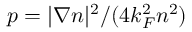<formula> <loc_0><loc_0><loc_500><loc_500>p = | \nabla n | ^ { 2 } / ( 4 k _ { F } ^ { 2 } n ^ { 2 } )</formula> 